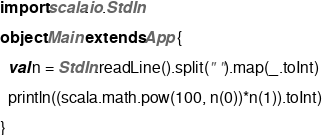Convert code to text. <code><loc_0><loc_0><loc_500><loc_500><_Scala_>import scala.io.StdIn

object Main extends App {

  val n = StdIn.readLine().split(" ").map(_.toInt)
  
  println((scala.math.pow(100, n(0))*n(1)).toInt)
  
}
</code> 